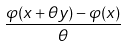Convert formula to latex. <formula><loc_0><loc_0><loc_500><loc_500>\frac { \varphi ( x + \theta y ) - \varphi ( x ) } { \theta }</formula> 